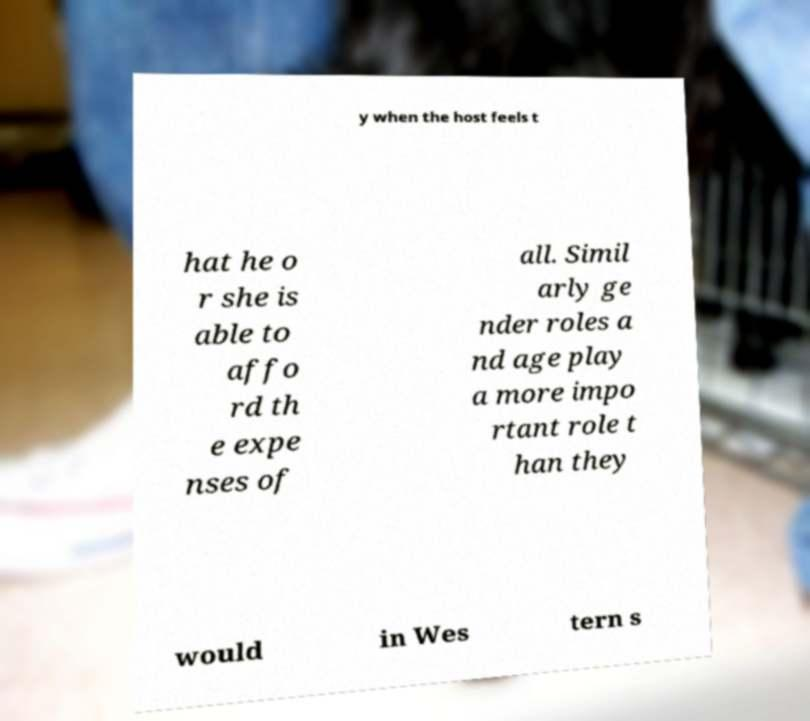I need the written content from this picture converted into text. Can you do that? y when the host feels t hat he o r she is able to affo rd th e expe nses of all. Simil arly ge nder roles a nd age play a more impo rtant role t han they would in Wes tern s 